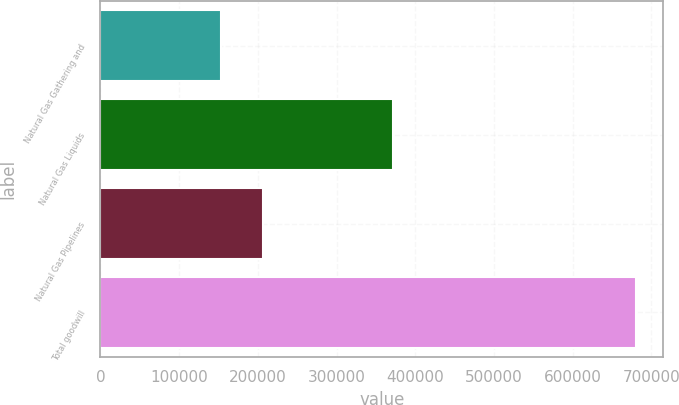<chart> <loc_0><loc_0><loc_500><loc_500><bar_chart><fcel>Natural Gas Gathering and<fcel>Natural Gas Liquids<fcel>Natural Gas Pipelines<fcel>Total goodwill<nl><fcel>153404<fcel>371217<fcel>206174<fcel>681100<nl></chart> 